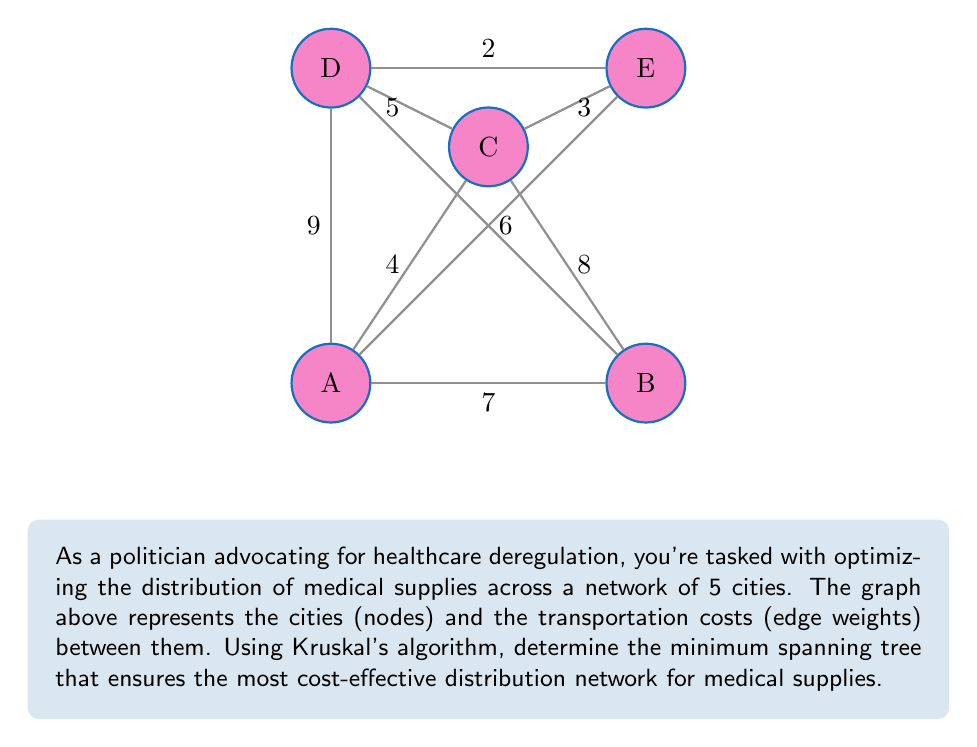Give your solution to this math problem. To solve this problem using Kruskal's algorithm, we follow these steps:

1) Sort all edges in ascending order of weight:
   DE (2), CE (3), AC (4), CD (5), BD (6), AB (7), BE (8), AD (9)

2) Start with an empty set and add edges in order, skipping those that would create a cycle:

   - Add DE (2)
   - Add CE (3)
   - Add AC (4)
   - Add CD (5) - skip, would create cycle
   - Add BD (6)

3) Stop when we have n-1 edges (where n is the number of nodes). We have 4 edges, which is correct for 5 nodes.

4) The resulting minimum spanning tree consists of edges:
   DE (2), CE (3), AC (4), BD (6)

5) Calculate the total cost:
   $$2 + 3 + 4 + 6 = 15$$

This minimum spanning tree represents the most cost-effective distribution network for medical supplies, connecting all cities with the minimum total transportation cost.
Answer: Minimum spanning tree: DE, CE, AC, BD; Total cost: 15 